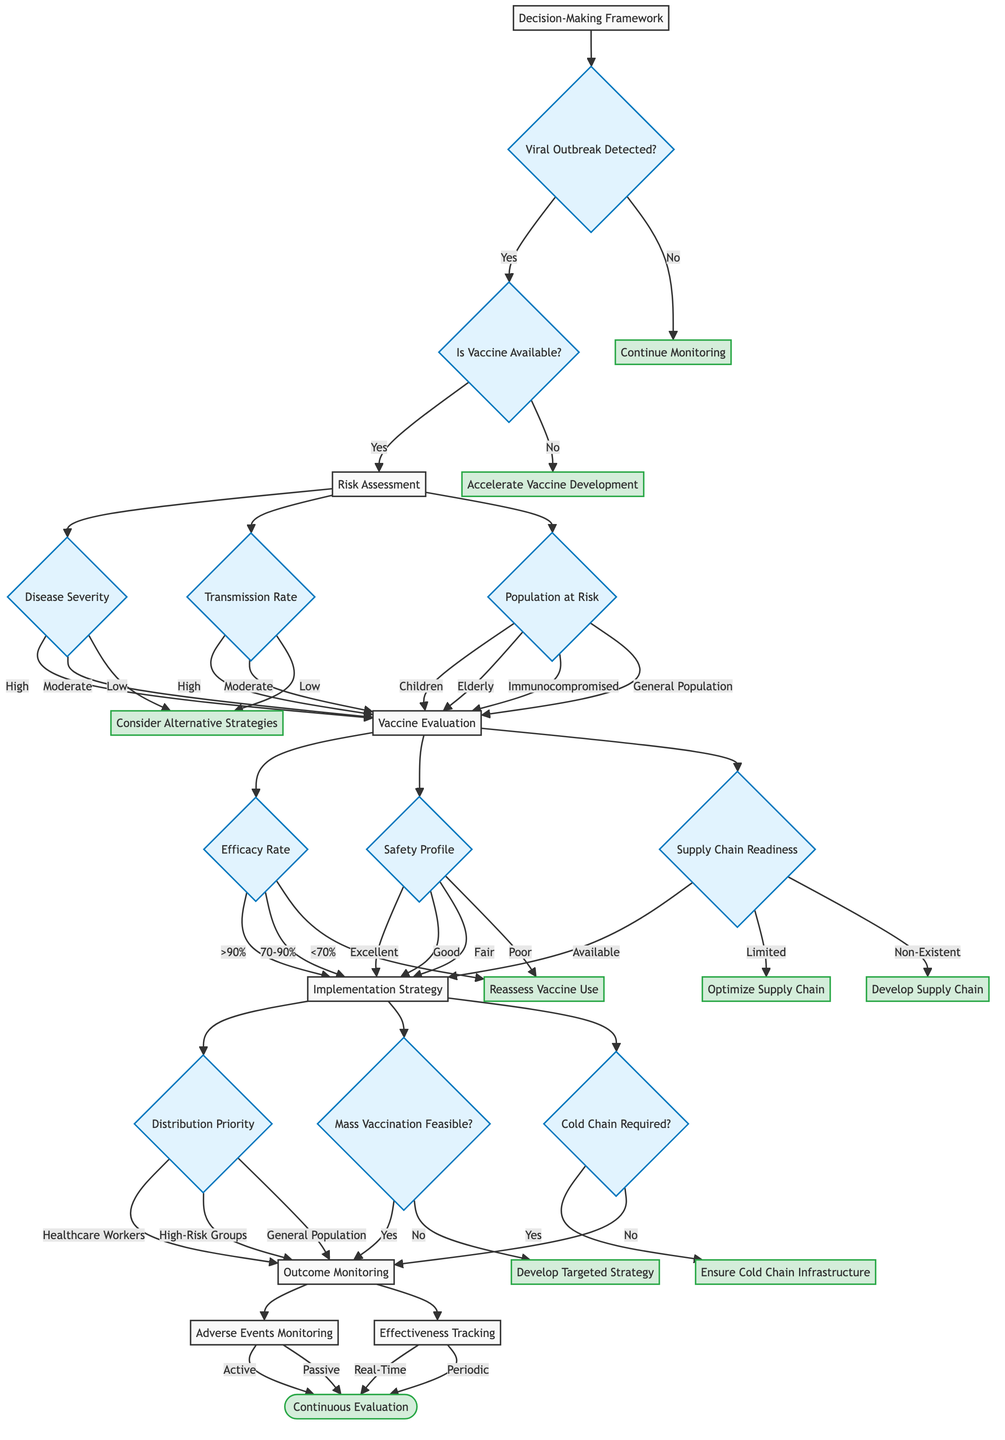What is the first decision point in the framework? The first decision point is whether a viral outbreak is detected. This is represented as the initial question in the flowchart.
Answer: Viral Outbreak Detected? If the vaccine is not available, what is the next step? If the vaccine is not available, the flowchart shows that the next step is to accelerate vaccine development, which directly follows that decision.
Answer: Accelerate Vaccine Development How many potential outcomes are there after the risk assessment? After the risk assessment, there are three pathways based on disease severity, transmission rate, and population at risk, leading to different evaluations.
Answer: Three What happens when the maximum efficacy rate is less than 70%? If the efficacy rate is less than 70%, the flowchart indicates that the next action is to reassess vaccine use, which is a distinct outcome.
Answer: Reassess Vaccine Use What is the final step after monitoring adverse events? The final step after monitoring adverse events is the continuous evaluation process, as outlined in the last part of the flowchart.
Answer: Continuous Evaluation Which group has the highest distribution priority? The group with the highest distribution priority according to the diagram is healthcare workers, indicated in the implementation strategy.
Answer: Healthcare Workers What action is suggested if the supply chain is limited? If the supply chain is limited, the suggested action is to optimize the supply chain, as noted in the evaluation section of the framework.
Answer: Optimize Supply Chain How does the decision tree handle situations where the cold chain is required? When the cold chain requirement is a "Yes," the tree indicates a need to ensure cold chain infrastructure before proceeding.
Answer: Ensure Cold Chain Infrastructure What type of monitoring method can be classified as "passive"? In the outcome monitoring section, passive monitoring is one of the methods listed alongside active monitoring for adverse events.
Answer: Passive What happens if mass vaccination is not feasible? If mass vaccination is determined to be not feasible, the next step is to develop a targeted strategy according to the implementation strategy branch in the flowchart.
Answer: Develop Targeted Strategy 